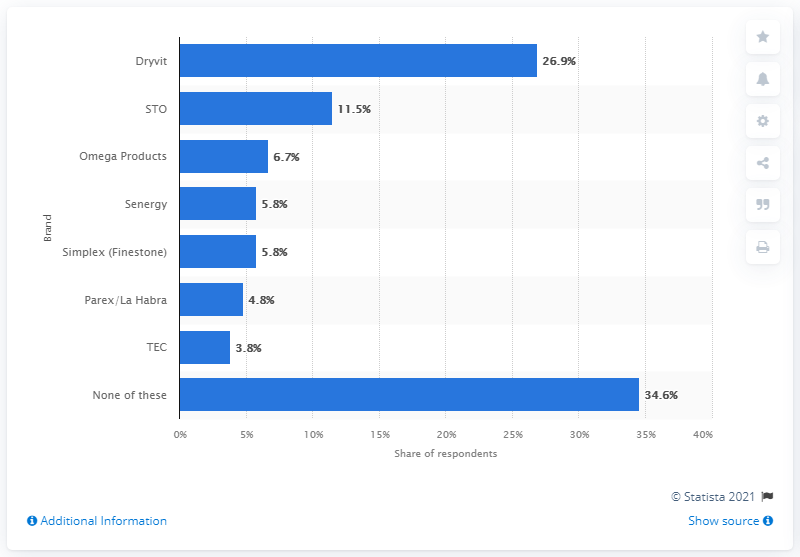Indicate a few pertinent items in this graphic. According to the data, 26.9% of respondents reported using Dryvit siding, which makes it the most popular brand of siding among respondents. 